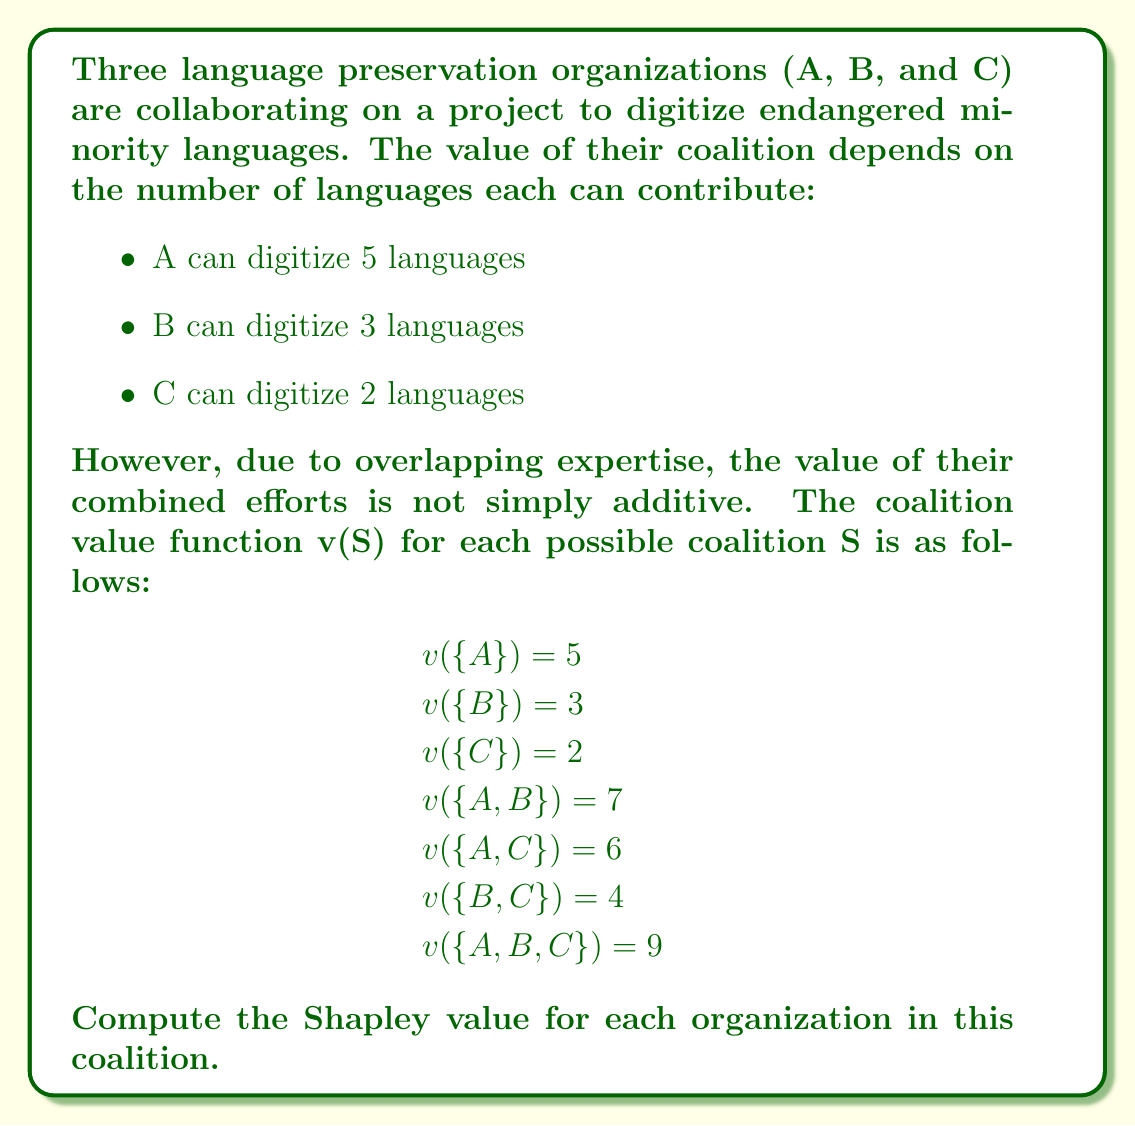Could you help me with this problem? To compute the Shapley value, we need to calculate the marginal contribution of each player (organization) in all possible orderings of the coalition. The Shapley value formula is:

$$\phi_i(v) = \sum_{S \subseteq N \setminus \{i\}} \frac{|S|!(n-|S|-1)!}{n!}[v(S \cup \{i\}) - v(S)]$$

Where:
- $\phi_i(v)$ is the Shapley value for player i
- N is the set of all players
- S is a subset of N that doesn't include player i
- n is the total number of players
- v(S) is the coalition value function

For this problem, we have 3 players (n = 3), so there are 3! = 6 possible orderings.

Let's calculate the marginal contribution for each player in each ordering:

1. ABC: A=5, B=2, C=2
2. ACB: A=5, C=1, B=3
3. BAC: B=3, A=4, C=2
4. BCA: B=3, C=1, A=5
5. CAB: C=2, A=4, B=3
6. CBA: C=2, B=2, A=5

Now, we sum up the marginal contributions for each player and divide by 6 (the number of orderings):

For A: $\phi_A = \frac{5 + 5 + 4 + 5 + 4 + 5}{6} = \frac{28}{6} = \frac{14}{3}$

For B: $\phi_B = \frac{2 + 3 + 3 + 3 + 3 + 2}{6} = \frac{16}{6} = \frac{8}{3}$

For C: $\phi_C = \frac{2 + 1 + 2 + 1 + 2 + 2}{6} = \frac{10}{6} = \frac{5}{3}$

We can verify that the sum of Shapley values equals the grand coalition value:

$$\frac{14}{3} + \frac{8}{3} + \frac{5}{3} = \frac{27}{3} = 9 = v(\{A,B,C\})$$
Answer: The Shapley values for the coalition are:

Organization A: $\frac{14}{3}$
Organization B: $\frac{8}{3}$
Organization C: $\frac{5}{3}$ 